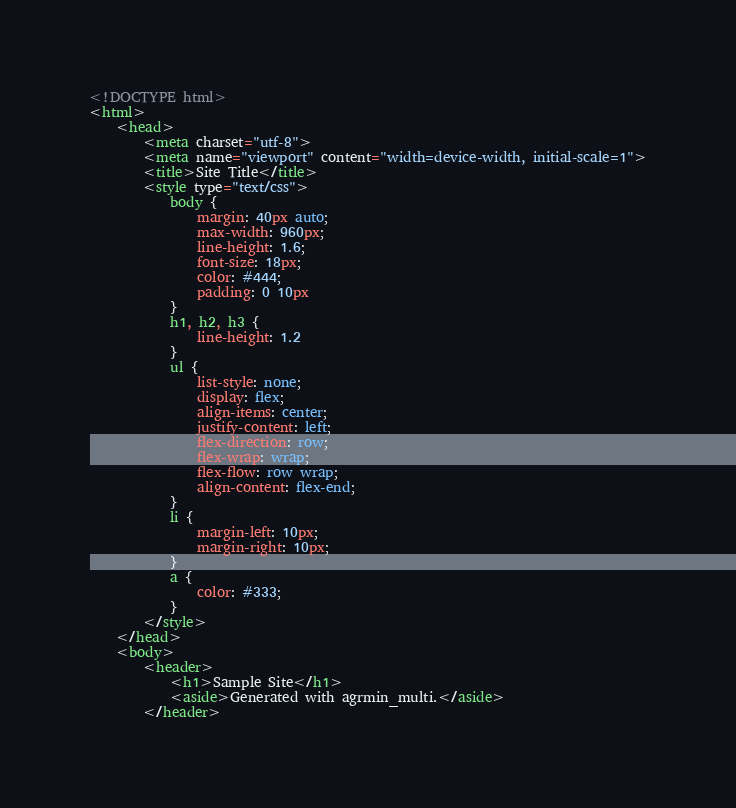Convert code to text. <code><loc_0><loc_0><loc_500><loc_500><_HTML_><!DOCTYPE html>
<html>
    <head>
        <meta charset="utf-8">
        <meta name="viewport" content="width=device-width, initial-scale=1">
        <title>Site Title</title>
        <style type="text/css">
            body {
                margin: 40px auto;
                max-width: 960px;
                line-height: 1.6;
                font-size: 18px;
                color: #444;
                padding: 0 10px
            }
            h1, h2, h3 {
                line-height: 1.2
            }
            ul {
                list-style: none;
                display: flex;
                align-items: center;
                justify-content: left;
                flex-direction: row;
                flex-wrap: wrap;
                flex-flow: row wrap;
                align-content: flex-end;
            }
            li {
                margin-left: 10px;
                margin-right: 10px;
            }
            a {
                color: #333;
            }
        </style>
    </head>
    <body>
        <header>
            <h1>Sample Site</h1>
            <aside>Generated with agrmin_multi.</aside>
        </header>
</code> 